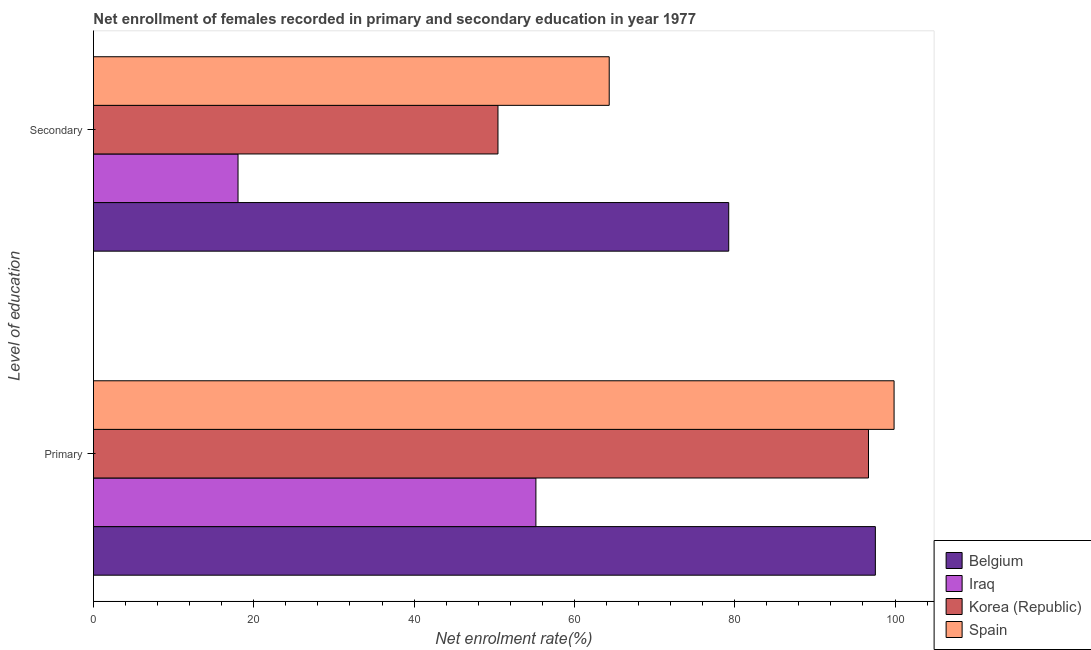How many groups of bars are there?
Make the answer very short. 2. Are the number of bars on each tick of the Y-axis equal?
Give a very brief answer. Yes. How many bars are there on the 1st tick from the bottom?
Offer a terse response. 4. What is the label of the 2nd group of bars from the top?
Make the answer very short. Primary. What is the enrollment rate in primary education in Iraq?
Your answer should be compact. 55.2. Across all countries, what is the maximum enrollment rate in primary education?
Give a very brief answer. 99.88. Across all countries, what is the minimum enrollment rate in primary education?
Your answer should be compact. 55.2. In which country was the enrollment rate in secondary education minimum?
Your answer should be very brief. Iraq. What is the total enrollment rate in secondary education in the graph?
Make the answer very short. 212.09. What is the difference between the enrollment rate in secondary education in Spain and that in Korea (Republic)?
Make the answer very short. 13.88. What is the difference between the enrollment rate in primary education in Spain and the enrollment rate in secondary education in Iraq?
Make the answer very short. 81.85. What is the average enrollment rate in primary education per country?
Your answer should be compact. 87.33. What is the difference between the enrollment rate in primary education and enrollment rate in secondary education in Spain?
Offer a very short reply. 35.54. In how many countries, is the enrollment rate in primary education greater than 16 %?
Provide a short and direct response. 4. What is the ratio of the enrollment rate in primary education in Korea (Republic) to that in Spain?
Your answer should be very brief. 0.97. What does the 3rd bar from the top in Secondary represents?
Your answer should be very brief. Iraq. What does the 2nd bar from the bottom in Secondary represents?
Your answer should be very brief. Iraq. Are the values on the major ticks of X-axis written in scientific E-notation?
Your answer should be very brief. No. Does the graph contain grids?
Provide a short and direct response. No. Where does the legend appear in the graph?
Offer a terse response. Bottom right. How many legend labels are there?
Your answer should be very brief. 4. What is the title of the graph?
Provide a short and direct response. Net enrollment of females recorded in primary and secondary education in year 1977. What is the label or title of the X-axis?
Provide a succinct answer. Net enrolment rate(%). What is the label or title of the Y-axis?
Give a very brief answer. Level of education. What is the Net enrolment rate(%) in Belgium in Primary?
Provide a short and direct response. 97.54. What is the Net enrolment rate(%) in Iraq in Primary?
Offer a very short reply. 55.2. What is the Net enrolment rate(%) in Korea (Republic) in Primary?
Make the answer very short. 96.69. What is the Net enrolment rate(%) of Spain in Primary?
Your response must be concise. 99.88. What is the Net enrolment rate(%) of Belgium in Secondary?
Keep it short and to the point. 79.25. What is the Net enrolment rate(%) of Iraq in Secondary?
Ensure brevity in your answer.  18.03. What is the Net enrolment rate(%) of Korea (Republic) in Secondary?
Provide a short and direct response. 50.46. What is the Net enrolment rate(%) in Spain in Secondary?
Ensure brevity in your answer.  64.34. Across all Level of education, what is the maximum Net enrolment rate(%) of Belgium?
Provide a succinct answer. 97.54. Across all Level of education, what is the maximum Net enrolment rate(%) of Iraq?
Provide a short and direct response. 55.2. Across all Level of education, what is the maximum Net enrolment rate(%) of Korea (Republic)?
Offer a terse response. 96.69. Across all Level of education, what is the maximum Net enrolment rate(%) of Spain?
Provide a succinct answer. 99.88. Across all Level of education, what is the minimum Net enrolment rate(%) of Belgium?
Your response must be concise. 79.25. Across all Level of education, what is the minimum Net enrolment rate(%) in Iraq?
Offer a very short reply. 18.03. Across all Level of education, what is the minimum Net enrolment rate(%) in Korea (Republic)?
Your answer should be very brief. 50.46. Across all Level of education, what is the minimum Net enrolment rate(%) in Spain?
Keep it short and to the point. 64.34. What is the total Net enrolment rate(%) in Belgium in the graph?
Make the answer very short. 176.8. What is the total Net enrolment rate(%) of Iraq in the graph?
Your answer should be very brief. 73.23. What is the total Net enrolment rate(%) of Korea (Republic) in the graph?
Provide a succinct answer. 147.15. What is the total Net enrolment rate(%) of Spain in the graph?
Provide a succinct answer. 164.22. What is the difference between the Net enrolment rate(%) of Belgium in Primary and that in Secondary?
Ensure brevity in your answer.  18.29. What is the difference between the Net enrolment rate(%) in Iraq in Primary and that in Secondary?
Make the answer very short. 37.16. What is the difference between the Net enrolment rate(%) of Korea (Republic) in Primary and that in Secondary?
Provide a succinct answer. 46.22. What is the difference between the Net enrolment rate(%) of Spain in Primary and that in Secondary?
Provide a short and direct response. 35.54. What is the difference between the Net enrolment rate(%) of Belgium in Primary and the Net enrolment rate(%) of Iraq in Secondary?
Ensure brevity in your answer.  79.51. What is the difference between the Net enrolment rate(%) of Belgium in Primary and the Net enrolment rate(%) of Korea (Republic) in Secondary?
Keep it short and to the point. 47.08. What is the difference between the Net enrolment rate(%) of Belgium in Primary and the Net enrolment rate(%) of Spain in Secondary?
Your response must be concise. 33.2. What is the difference between the Net enrolment rate(%) in Iraq in Primary and the Net enrolment rate(%) in Korea (Republic) in Secondary?
Your response must be concise. 4.73. What is the difference between the Net enrolment rate(%) in Iraq in Primary and the Net enrolment rate(%) in Spain in Secondary?
Offer a terse response. -9.15. What is the difference between the Net enrolment rate(%) in Korea (Republic) in Primary and the Net enrolment rate(%) in Spain in Secondary?
Your answer should be compact. 32.34. What is the average Net enrolment rate(%) of Belgium per Level of education?
Your response must be concise. 88.4. What is the average Net enrolment rate(%) of Iraq per Level of education?
Make the answer very short. 36.62. What is the average Net enrolment rate(%) in Korea (Republic) per Level of education?
Ensure brevity in your answer.  73.57. What is the average Net enrolment rate(%) in Spain per Level of education?
Provide a succinct answer. 82.11. What is the difference between the Net enrolment rate(%) of Belgium and Net enrolment rate(%) of Iraq in Primary?
Ensure brevity in your answer.  42.35. What is the difference between the Net enrolment rate(%) in Belgium and Net enrolment rate(%) in Korea (Republic) in Primary?
Your response must be concise. 0.86. What is the difference between the Net enrolment rate(%) of Belgium and Net enrolment rate(%) of Spain in Primary?
Your answer should be compact. -2.33. What is the difference between the Net enrolment rate(%) of Iraq and Net enrolment rate(%) of Korea (Republic) in Primary?
Your answer should be very brief. -41.49. What is the difference between the Net enrolment rate(%) of Iraq and Net enrolment rate(%) of Spain in Primary?
Your answer should be very brief. -44.68. What is the difference between the Net enrolment rate(%) of Korea (Republic) and Net enrolment rate(%) of Spain in Primary?
Your answer should be very brief. -3.19. What is the difference between the Net enrolment rate(%) in Belgium and Net enrolment rate(%) in Iraq in Secondary?
Ensure brevity in your answer.  61.22. What is the difference between the Net enrolment rate(%) of Belgium and Net enrolment rate(%) of Korea (Republic) in Secondary?
Keep it short and to the point. 28.79. What is the difference between the Net enrolment rate(%) of Belgium and Net enrolment rate(%) of Spain in Secondary?
Make the answer very short. 14.91. What is the difference between the Net enrolment rate(%) in Iraq and Net enrolment rate(%) in Korea (Republic) in Secondary?
Your answer should be compact. -32.43. What is the difference between the Net enrolment rate(%) of Iraq and Net enrolment rate(%) of Spain in Secondary?
Provide a short and direct response. -46.31. What is the difference between the Net enrolment rate(%) of Korea (Republic) and Net enrolment rate(%) of Spain in Secondary?
Offer a very short reply. -13.88. What is the ratio of the Net enrolment rate(%) of Belgium in Primary to that in Secondary?
Provide a succinct answer. 1.23. What is the ratio of the Net enrolment rate(%) of Iraq in Primary to that in Secondary?
Offer a very short reply. 3.06. What is the ratio of the Net enrolment rate(%) of Korea (Republic) in Primary to that in Secondary?
Make the answer very short. 1.92. What is the ratio of the Net enrolment rate(%) of Spain in Primary to that in Secondary?
Offer a terse response. 1.55. What is the difference between the highest and the second highest Net enrolment rate(%) of Belgium?
Your response must be concise. 18.29. What is the difference between the highest and the second highest Net enrolment rate(%) of Iraq?
Provide a succinct answer. 37.16. What is the difference between the highest and the second highest Net enrolment rate(%) of Korea (Republic)?
Offer a terse response. 46.22. What is the difference between the highest and the second highest Net enrolment rate(%) of Spain?
Your answer should be very brief. 35.54. What is the difference between the highest and the lowest Net enrolment rate(%) in Belgium?
Your answer should be compact. 18.29. What is the difference between the highest and the lowest Net enrolment rate(%) in Iraq?
Make the answer very short. 37.16. What is the difference between the highest and the lowest Net enrolment rate(%) in Korea (Republic)?
Your response must be concise. 46.22. What is the difference between the highest and the lowest Net enrolment rate(%) of Spain?
Provide a succinct answer. 35.54. 